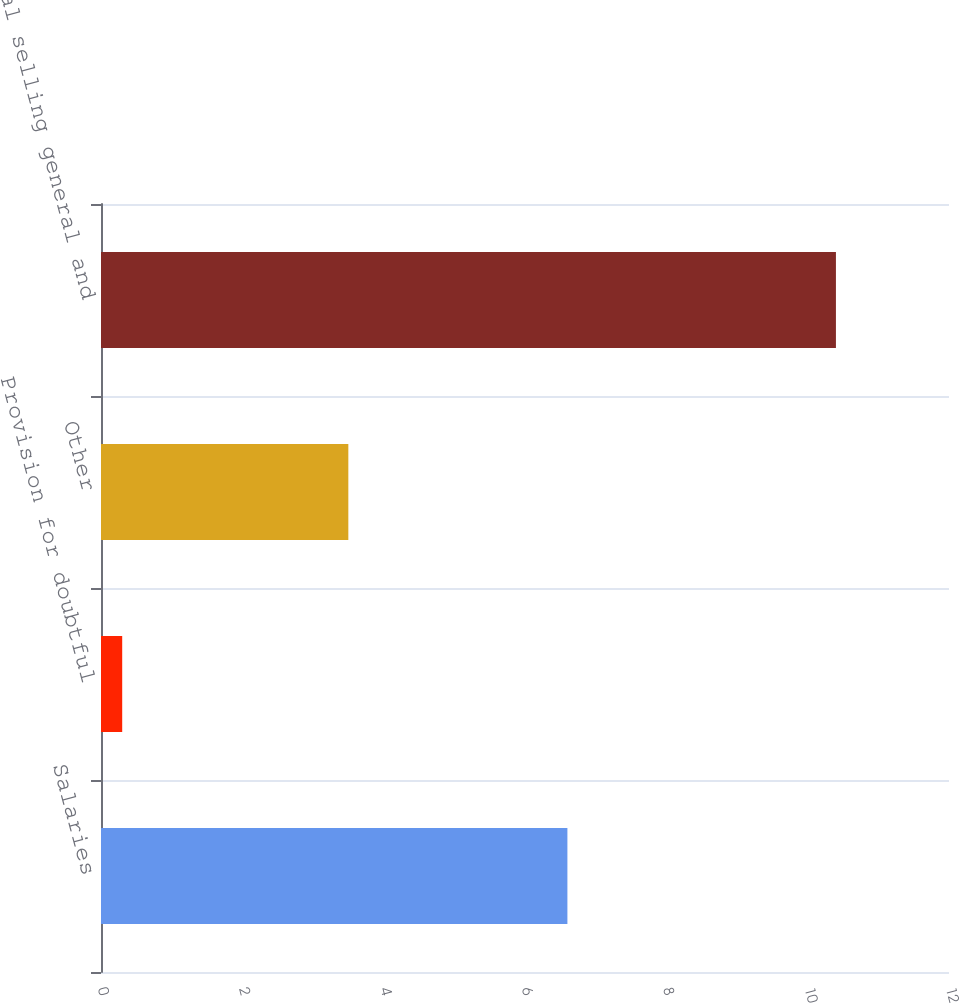Convert chart to OTSL. <chart><loc_0><loc_0><loc_500><loc_500><bar_chart><fcel>Salaries<fcel>Provision for doubtful<fcel>Other<fcel>Total selling general and<nl><fcel>6.6<fcel>0.3<fcel>3.5<fcel>10.4<nl></chart> 